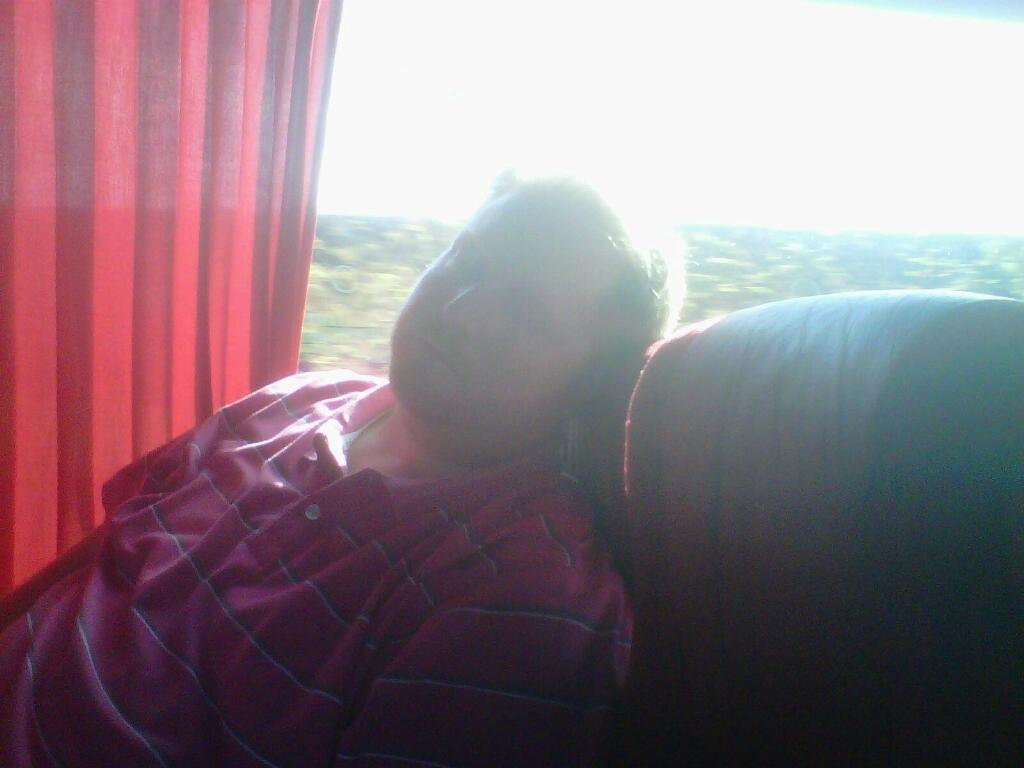Who or what is the main subject in the image? There is a person in the image. What is the person doing in the image? The person is sitting in a chair. What can be seen in the background of the image? There is a curtain and a window in the background of the image. What type of wilderness can be seen through the window in the image? There is no wilderness visible through the window in the image; only the curtain and the window are present in the background. 